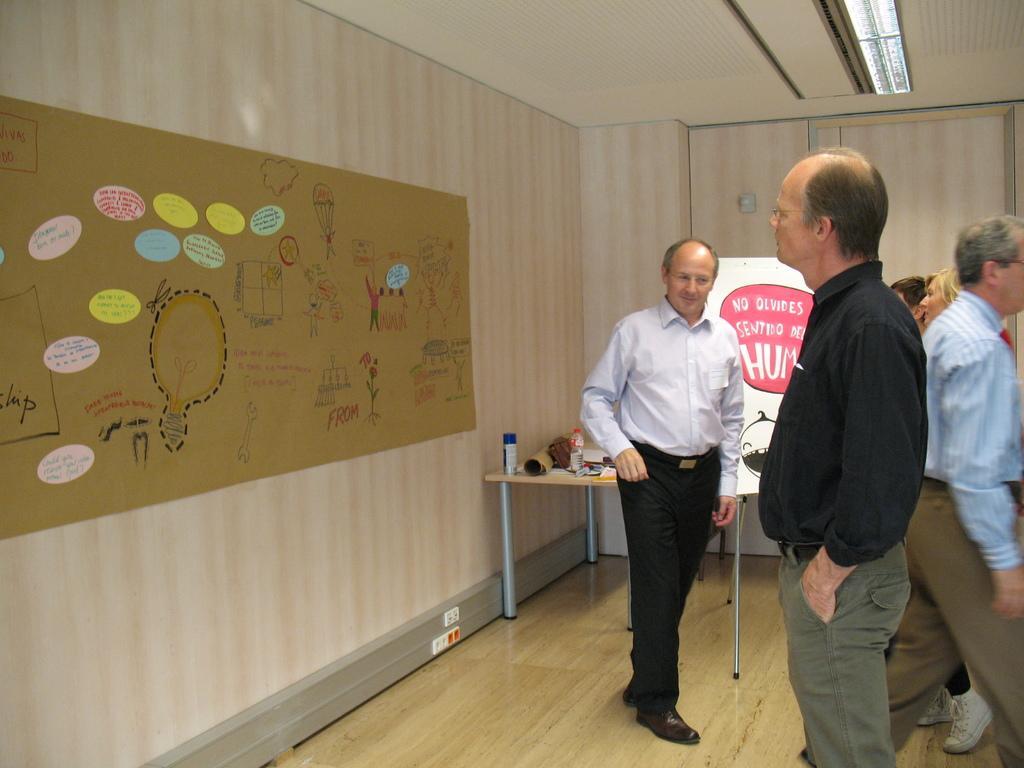Can you describe this image briefly? In this picture there are people standing and there is a poster on the wall with a table over here. 